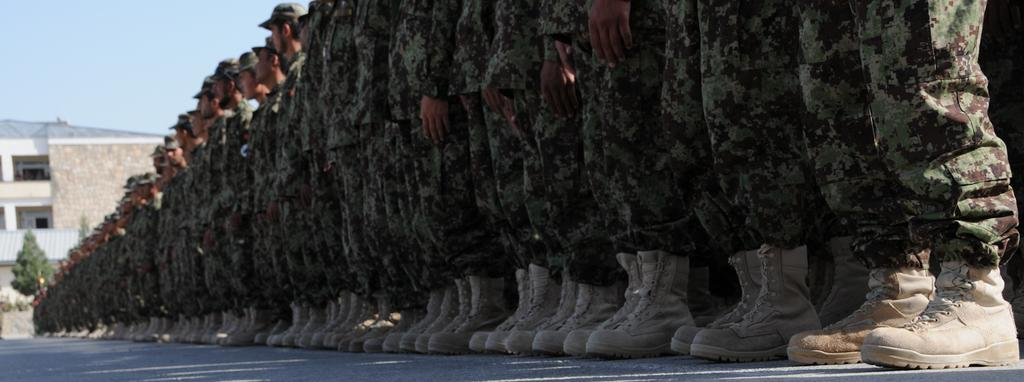What type of clothing are the people wearing in the image? The people are wearing military uniforms in the image. What type of footwear are the people wearing? The people are wearing shoes in the image. Where are the people standing in the image? The people are standing on a road in the image. What is located on the left side of the image? There is a building and trees on the left side of the image. What is visible in the image besides the people and the road? The sky is visible in the image. What type of bun is being served at the event in the image? There is no event or bun present in the image; it features people wearing military uniforms standing on a road. What is the weather like in the image? The provided facts do not mention the weather, so we cannot determine the weather conditions from the image. 